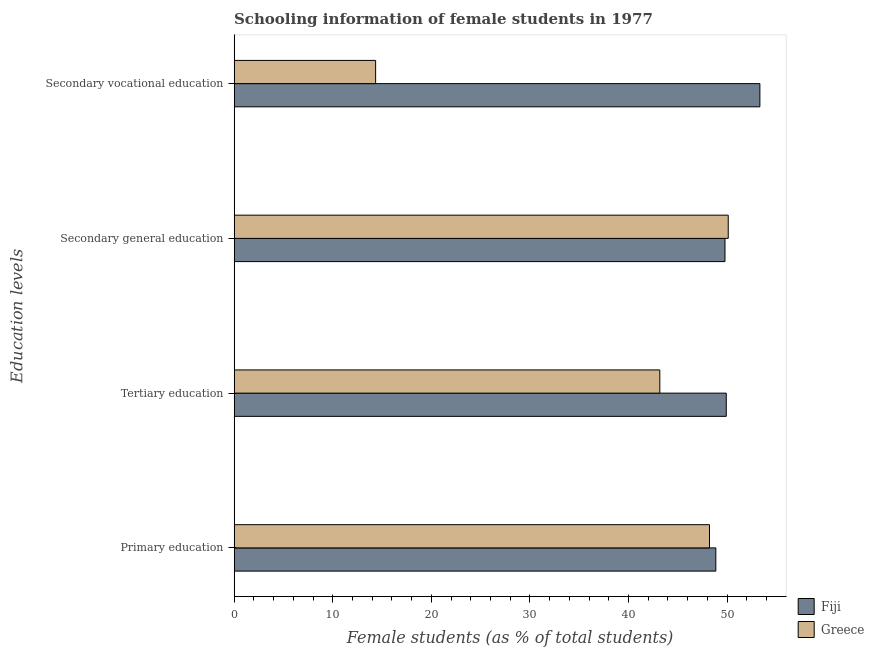How many different coloured bars are there?
Keep it short and to the point. 2. Are the number of bars per tick equal to the number of legend labels?
Offer a terse response. Yes. Are the number of bars on each tick of the Y-axis equal?
Offer a very short reply. Yes. How many bars are there on the 1st tick from the top?
Your response must be concise. 2. What is the percentage of female students in secondary education in Greece?
Keep it short and to the point. 50.11. Across all countries, what is the maximum percentage of female students in secondary vocational education?
Offer a terse response. 53.33. Across all countries, what is the minimum percentage of female students in tertiary education?
Offer a very short reply. 43.18. In which country was the percentage of female students in primary education maximum?
Keep it short and to the point. Fiji. What is the total percentage of female students in secondary vocational education in the graph?
Give a very brief answer. 67.68. What is the difference between the percentage of female students in primary education in Fiji and that in Greece?
Keep it short and to the point. 0.64. What is the difference between the percentage of female students in secondary education in Greece and the percentage of female students in secondary vocational education in Fiji?
Make the answer very short. -3.21. What is the average percentage of female students in primary education per country?
Provide a short and direct response. 48.53. What is the difference between the percentage of female students in tertiary education and percentage of female students in primary education in Fiji?
Keep it short and to the point. 1.06. What is the ratio of the percentage of female students in secondary vocational education in Greece to that in Fiji?
Your response must be concise. 0.27. What is the difference between the highest and the second highest percentage of female students in secondary vocational education?
Keep it short and to the point. 38.97. What is the difference between the highest and the lowest percentage of female students in secondary education?
Ensure brevity in your answer.  0.33. In how many countries, is the percentage of female students in secondary vocational education greater than the average percentage of female students in secondary vocational education taken over all countries?
Provide a succinct answer. 1. How many bars are there?
Ensure brevity in your answer.  8. What is the difference between two consecutive major ticks on the X-axis?
Your answer should be compact. 10. Does the graph contain grids?
Your response must be concise. No. How are the legend labels stacked?
Make the answer very short. Vertical. What is the title of the graph?
Your answer should be very brief. Schooling information of female students in 1977. Does "Serbia" appear as one of the legend labels in the graph?
Your answer should be very brief. No. What is the label or title of the X-axis?
Offer a terse response. Female students (as % of total students). What is the label or title of the Y-axis?
Give a very brief answer. Education levels. What is the Female students (as % of total students) in Fiji in Primary education?
Your response must be concise. 48.86. What is the Female students (as % of total students) of Greece in Primary education?
Keep it short and to the point. 48.21. What is the Female students (as % of total students) in Fiji in Tertiary education?
Give a very brief answer. 49.91. What is the Female students (as % of total students) in Greece in Tertiary education?
Ensure brevity in your answer.  43.18. What is the Female students (as % of total students) of Fiji in Secondary general education?
Offer a very short reply. 49.78. What is the Female students (as % of total students) in Greece in Secondary general education?
Your answer should be compact. 50.11. What is the Female students (as % of total students) in Fiji in Secondary vocational education?
Provide a succinct answer. 53.33. What is the Female students (as % of total students) in Greece in Secondary vocational education?
Provide a succinct answer. 14.35. Across all Education levels, what is the maximum Female students (as % of total students) in Fiji?
Keep it short and to the point. 53.33. Across all Education levels, what is the maximum Female students (as % of total students) in Greece?
Keep it short and to the point. 50.11. Across all Education levels, what is the minimum Female students (as % of total students) of Fiji?
Make the answer very short. 48.86. Across all Education levels, what is the minimum Female students (as % of total students) in Greece?
Provide a short and direct response. 14.35. What is the total Female students (as % of total students) in Fiji in the graph?
Your answer should be very brief. 201.88. What is the total Female students (as % of total students) of Greece in the graph?
Provide a succinct answer. 155.85. What is the difference between the Female students (as % of total students) in Fiji in Primary education and that in Tertiary education?
Offer a terse response. -1.06. What is the difference between the Female students (as % of total students) in Greece in Primary education and that in Tertiary education?
Ensure brevity in your answer.  5.04. What is the difference between the Female students (as % of total students) in Fiji in Primary education and that in Secondary general education?
Your answer should be compact. -0.93. What is the difference between the Female students (as % of total students) in Greece in Primary education and that in Secondary general education?
Your answer should be compact. -1.9. What is the difference between the Female students (as % of total students) of Fiji in Primary education and that in Secondary vocational education?
Ensure brevity in your answer.  -4.47. What is the difference between the Female students (as % of total students) of Greece in Primary education and that in Secondary vocational education?
Ensure brevity in your answer.  33.86. What is the difference between the Female students (as % of total students) of Fiji in Tertiary education and that in Secondary general education?
Offer a very short reply. 0.13. What is the difference between the Female students (as % of total students) of Greece in Tertiary education and that in Secondary general education?
Offer a terse response. -6.94. What is the difference between the Female students (as % of total students) of Fiji in Tertiary education and that in Secondary vocational education?
Ensure brevity in your answer.  -3.41. What is the difference between the Female students (as % of total students) in Greece in Tertiary education and that in Secondary vocational education?
Make the answer very short. 28.82. What is the difference between the Female students (as % of total students) of Fiji in Secondary general education and that in Secondary vocational education?
Your response must be concise. -3.54. What is the difference between the Female students (as % of total students) in Greece in Secondary general education and that in Secondary vocational education?
Offer a very short reply. 35.76. What is the difference between the Female students (as % of total students) in Fiji in Primary education and the Female students (as % of total students) in Greece in Tertiary education?
Ensure brevity in your answer.  5.68. What is the difference between the Female students (as % of total students) in Fiji in Primary education and the Female students (as % of total students) in Greece in Secondary general education?
Provide a short and direct response. -1.26. What is the difference between the Female students (as % of total students) of Fiji in Primary education and the Female students (as % of total students) of Greece in Secondary vocational education?
Keep it short and to the point. 34.5. What is the difference between the Female students (as % of total students) of Fiji in Tertiary education and the Female students (as % of total students) of Greece in Secondary general education?
Provide a succinct answer. -0.2. What is the difference between the Female students (as % of total students) in Fiji in Tertiary education and the Female students (as % of total students) in Greece in Secondary vocational education?
Provide a succinct answer. 35.56. What is the difference between the Female students (as % of total students) in Fiji in Secondary general education and the Female students (as % of total students) in Greece in Secondary vocational education?
Provide a succinct answer. 35.43. What is the average Female students (as % of total students) in Fiji per Education levels?
Your answer should be very brief. 50.47. What is the average Female students (as % of total students) in Greece per Education levels?
Provide a short and direct response. 38.96. What is the difference between the Female students (as % of total students) in Fiji and Female students (as % of total students) in Greece in Primary education?
Provide a short and direct response. 0.64. What is the difference between the Female students (as % of total students) of Fiji and Female students (as % of total students) of Greece in Tertiary education?
Make the answer very short. 6.74. What is the difference between the Female students (as % of total students) of Fiji and Female students (as % of total students) of Greece in Secondary general education?
Provide a succinct answer. -0.33. What is the difference between the Female students (as % of total students) in Fiji and Female students (as % of total students) in Greece in Secondary vocational education?
Offer a terse response. 38.97. What is the ratio of the Female students (as % of total students) of Fiji in Primary education to that in Tertiary education?
Your answer should be compact. 0.98. What is the ratio of the Female students (as % of total students) of Greece in Primary education to that in Tertiary education?
Offer a very short reply. 1.12. What is the ratio of the Female students (as % of total students) in Fiji in Primary education to that in Secondary general education?
Your answer should be compact. 0.98. What is the ratio of the Female students (as % of total students) of Greece in Primary education to that in Secondary general education?
Offer a very short reply. 0.96. What is the ratio of the Female students (as % of total students) in Fiji in Primary education to that in Secondary vocational education?
Your response must be concise. 0.92. What is the ratio of the Female students (as % of total students) in Greece in Primary education to that in Secondary vocational education?
Offer a very short reply. 3.36. What is the ratio of the Female students (as % of total students) of Greece in Tertiary education to that in Secondary general education?
Offer a terse response. 0.86. What is the ratio of the Female students (as % of total students) of Fiji in Tertiary education to that in Secondary vocational education?
Offer a terse response. 0.94. What is the ratio of the Female students (as % of total students) in Greece in Tertiary education to that in Secondary vocational education?
Ensure brevity in your answer.  3.01. What is the ratio of the Female students (as % of total students) of Fiji in Secondary general education to that in Secondary vocational education?
Provide a succinct answer. 0.93. What is the ratio of the Female students (as % of total students) in Greece in Secondary general education to that in Secondary vocational education?
Offer a terse response. 3.49. What is the difference between the highest and the second highest Female students (as % of total students) of Fiji?
Your answer should be compact. 3.41. What is the difference between the highest and the second highest Female students (as % of total students) of Greece?
Your answer should be compact. 1.9. What is the difference between the highest and the lowest Female students (as % of total students) in Fiji?
Provide a short and direct response. 4.47. What is the difference between the highest and the lowest Female students (as % of total students) of Greece?
Make the answer very short. 35.76. 